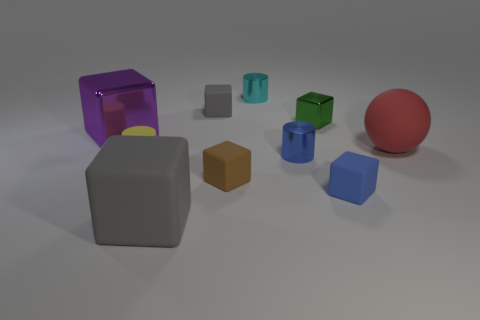Are there more brown things than gray matte things?
Provide a succinct answer. No. There is a cylinder behind the gray block behind the cube to the left of the yellow thing; what is its size?
Offer a terse response. Small. Is the size of the blue metal cylinder the same as the yellow object that is left of the large matte cube?
Your answer should be compact. Yes. Are there fewer blue matte things to the right of the big red matte thing than large matte balls?
Offer a terse response. Yes. How many small things have the same color as the big matte block?
Your answer should be very brief. 1. Are there fewer big yellow metallic balls than large spheres?
Make the answer very short. Yes. Is the brown cube made of the same material as the small gray cube?
Ensure brevity in your answer.  Yes. What number of other things are the same size as the cyan metal object?
Your answer should be compact. 6. What color is the big thing that is in front of the small blue rubber object that is right of the large gray matte object?
Provide a short and direct response. Gray. What number of other things are there of the same shape as the small brown matte object?
Offer a terse response. 5. 